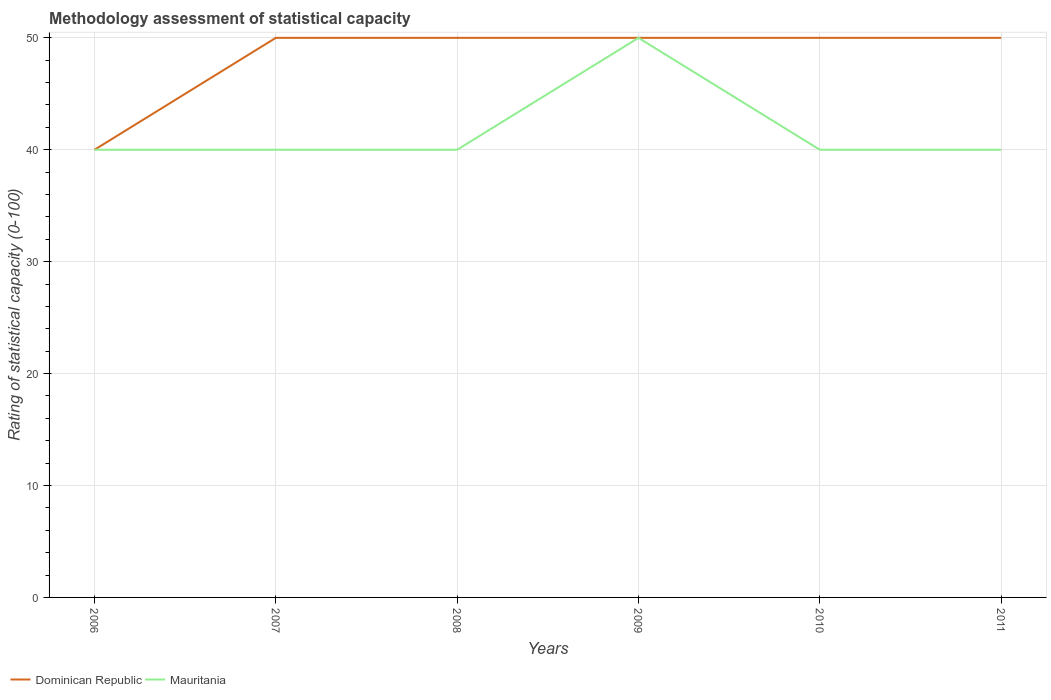Does the line corresponding to Mauritania intersect with the line corresponding to Dominican Republic?
Your response must be concise. Yes. Is the number of lines equal to the number of legend labels?
Your answer should be compact. Yes. Across all years, what is the maximum rating of statistical capacity in Mauritania?
Offer a terse response. 40. What is the total rating of statistical capacity in Dominican Republic in the graph?
Offer a very short reply. 0. What is the difference between the highest and the second highest rating of statistical capacity in Dominican Republic?
Provide a succinct answer. 10. What is the difference between the highest and the lowest rating of statistical capacity in Dominican Republic?
Offer a terse response. 5. Is the rating of statistical capacity in Dominican Republic strictly greater than the rating of statistical capacity in Mauritania over the years?
Your response must be concise. No. How many lines are there?
Ensure brevity in your answer.  2. Does the graph contain any zero values?
Provide a succinct answer. No. Where does the legend appear in the graph?
Ensure brevity in your answer.  Bottom left. How many legend labels are there?
Your response must be concise. 2. What is the title of the graph?
Provide a succinct answer. Methodology assessment of statistical capacity. Does "Malaysia" appear as one of the legend labels in the graph?
Ensure brevity in your answer.  No. What is the label or title of the Y-axis?
Give a very brief answer. Rating of statistical capacity (0-100). What is the Rating of statistical capacity (0-100) of Dominican Republic in 2006?
Your answer should be very brief. 40. What is the Rating of statistical capacity (0-100) of Mauritania in 2006?
Ensure brevity in your answer.  40. What is the Rating of statistical capacity (0-100) of Dominican Republic in 2007?
Offer a terse response. 50. What is the Rating of statistical capacity (0-100) in Mauritania in 2007?
Your answer should be compact. 40. What is the Rating of statistical capacity (0-100) of Dominican Republic in 2008?
Offer a very short reply. 50. What is the Rating of statistical capacity (0-100) of Mauritania in 2008?
Offer a terse response. 40. What is the Rating of statistical capacity (0-100) in Mauritania in 2011?
Your answer should be compact. 40. Across all years, what is the maximum Rating of statistical capacity (0-100) in Mauritania?
Offer a terse response. 50. Across all years, what is the minimum Rating of statistical capacity (0-100) in Mauritania?
Ensure brevity in your answer.  40. What is the total Rating of statistical capacity (0-100) of Dominican Republic in the graph?
Offer a terse response. 290. What is the total Rating of statistical capacity (0-100) of Mauritania in the graph?
Make the answer very short. 250. What is the difference between the Rating of statistical capacity (0-100) in Mauritania in 2006 and that in 2007?
Your response must be concise. 0. What is the difference between the Rating of statistical capacity (0-100) of Dominican Republic in 2006 and that in 2008?
Provide a short and direct response. -10. What is the difference between the Rating of statistical capacity (0-100) of Mauritania in 2006 and that in 2009?
Keep it short and to the point. -10. What is the difference between the Rating of statistical capacity (0-100) of Dominican Republic in 2006 and that in 2010?
Provide a succinct answer. -10. What is the difference between the Rating of statistical capacity (0-100) of Mauritania in 2006 and that in 2010?
Your answer should be compact. 0. What is the difference between the Rating of statistical capacity (0-100) in Mauritania in 2006 and that in 2011?
Provide a succinct answer. 0. What is the difference between the Rating of statistical capacity (0-100) of Dominican Republic in 2007 and that in 2009?
Your answer should be compact. 0. What is the difference between the Rating of statistical capacity (0-100) of Mauritania in 2007 and that in 2009?
Offer a very short reply. -10. What is the difference between the Rating of statistical capacity (0-100) of Dominican Republic in 2008 and that in 2009?
Your answer should be very brief. 0. What is the difference between the Rating of statistical capacity (0-100) of Mauritania in 2008 and that in 2010?
Your answer should be very brief. 0. What is the difference between the Rating of statistical capacity (0-100) of Dominican Republic in 2008 and that in 2011?
Make the answer very short. 0. What is the difference between the Rating of statistical capacity (0-100) of Dominican Republic in 2009 and that in 2010?
Keep it short and to the point. 0. What is the difference between the Rating of statistical capacity (0-100) in Mauritania in 2009 and that in 2010?
Provide a short and direct response. 10. What is the difference between the Rating of statistical capacity (0-100) of Dominican Republic in 2009 and that in 2011?
Your answer should be very brief. 0. What is the difference between the Rating of statistical capacity (0-100) in Mauritania in 2009 and that in 2011?
Provide a succinct answer. 10. What is the difference between the Rating of statistical capacity (0-100) in Dominican Republic in 2010 and that in 2011?
Offer a terse response. 0. What is the difference between the Rating of statistical capacity (0-100) of Mauritania in 2010 and that in 2011?
Give a very brief answer. 0. What is the difference between the Rating of statistical capacity (0-100) of Dominican Republic in 2006 and the Rating of statistical capacity (0-100) of Mauritania in 2011?
Your answer should be compact. 0. What is the difference between the Rating of statistical capacity (0-100) in Dominican Republic in 2007 and the Rating of statistical capacity (0-100) in Mauritania in 2008?
Your answer should be compact. 10. What is the difference between the Rating of statistical capacity (0-100) of Dominican Republic in 2007 and the Rating of statistical capacity (0-100) of Mauritania in 2009?
Offer a terse response. 0. What is the difference between the Rating of statistical capacity (0-100) in Dominican Republic in 2007 and the Rating of statistical capacity (0-100) in Mauritania in 2011?
Make the answer very short. 10. What is the difference between the Rating of statistical capacity (0-100) in Dominican Republic in 2008 and the Rating of statistical capacity (0-100) in Mauritania in 2009?
Your answer should be very brief. 0. What is the difference between the Rating of statistical capacity (0-100) in Dominican Republic in 2008 and the Rating of statistical capacity (0-100) in Mauritania in 2010?
Give a very brief answer. 10. What is the difference between the Rating of statistical capacity (0-100) in Dominican Republic in 2009 and the Rating of statistical capacity (0-100) in Mauritania in 2010?
Give a very brief answer. 10. What is the difference between the Rating of statistical capacity (0-100) of Dominican Republic in 2010 and the Rating of statistical capacity (0-100) of Mauritania in 2011?
Your answer should be compact. 10. What is the average Rating of statistical capacity (0-100) of Dominican Republic per year?
Provide a short and direct response. 48.33. What is the average Rating of statistical capacity (0-100) in Mauritania per year?
Your answer should be compact. 41.67. In the year 2007, what is the difference between the Rating of statistical capacity (0-100) of Dominican Republic and Rating of statistical capacity (0-100) of Mauritania?
Your answer should be very brief. 10. In the year 2008, what is the difference between the Rating of statistical capacity (0-100) of Dominican Republic and Rating of statistical capacity (0-100) of Mauritania?
Your answer should be compact. 10. In the year 2010, what is the difference between the Rating of statistical capacity (0-100) in Dominican Republic and Rating of statistical capacity (0-100) in Mauritania?
Make the answer very short. 10. What is the ratio of the Rating of statistical capacity (0-100) in Dominican Republic in 2006 to that in 2007?
Keep it short and to the point. 0.8. What is the ratio of the Rating of statistical capacity (0-100) of Mauritania in 2006 to that in 2007?
Make the answer very short. 1. What is the ratio of the Rating of statistical capacity (0-100) of Dominican Republic in 2006 to that in 2008?
Offer a very short reply. 0.8. What is the ratio of the Rating of statistical capacity (0-100) in Mauritania in 2006 to that in 2008?
Provide a succinct answer. 1. What is the ratio of the Rating of statistical capacity (0-100) in Dominican Republic in 2006 to that in 2011?
Offer a terse response. 0.8. What is the ratio of the Rating of statistical capacity (0-100) in Mauritania in 2006 to that in 2011?
Make the answer very short. 1. What is the ratio of the Rating of statistical capacity (0-100) of Mauritania in 2007 to that in 2008?
Provide a succinct answer. 1. What is the ratio of the Rating of statistical capacity (0-100) of Dominican Republic in 2007 to that in 2009?
Offer a terse response. 1. What is the ratio of the Rating of statistical capacity (0-100) of Mauritania in 2007 to that in 2009?
Your answer should be compact. 0.8. What is the ratio of the Rating of statistical capacity (0-100) in Dominican Republic in 2007 to that in 2010?
Your answer should be very brief. 1. What is the ratio of the Rating of statistical capacity (0-100) in Dominican Republic in 2008 to that in 2009?
Provide a short and direct response. 1. What is the ratio of the Rating of statistical capacity (0-100) of Mauritania in 2008 to that in 2010?
Your response must be concise. 1. What is the ratio of the Rating of statistical capacity (0-100) of Dominican Republic in 2008 to that in 2011?
Provide a short and direct response. 1. What is the ratio of the Rating of statistical capacity (0-100) in Mauritania in 2009 to that in 2010?
Make the answer very short. 1.25. What is the ratio of the Rating of statistical capacity (0-100) of Dominican Republic in 2009 to that in 2011?
Keep it short and to the point. 1. What is the ratio of the Rating of statistical capacity (0-100) in Mauritania in 2009 to that in 2011?
Offer a very short reply. 1.25. What is the ratio of the Rating of statistical capacity (0-100) in Dominican Republic in 2010 to that in 2011?
Provide a short and direct response. 1. What is the ratio of the Rating of statistical capacity (0-100) in Mauritania in 2010 to that in 2011?
Offer a very short reply. 1. What is the difference between the highest and the second highest Rating of statistical capacity (0-100) of Mauritania?
Offer a terse response. 10. What is the difference between the highest and the lowest Rating of statistical capacity (0-100) in Dominican Republic?
Your answer should be very brief. 10. 